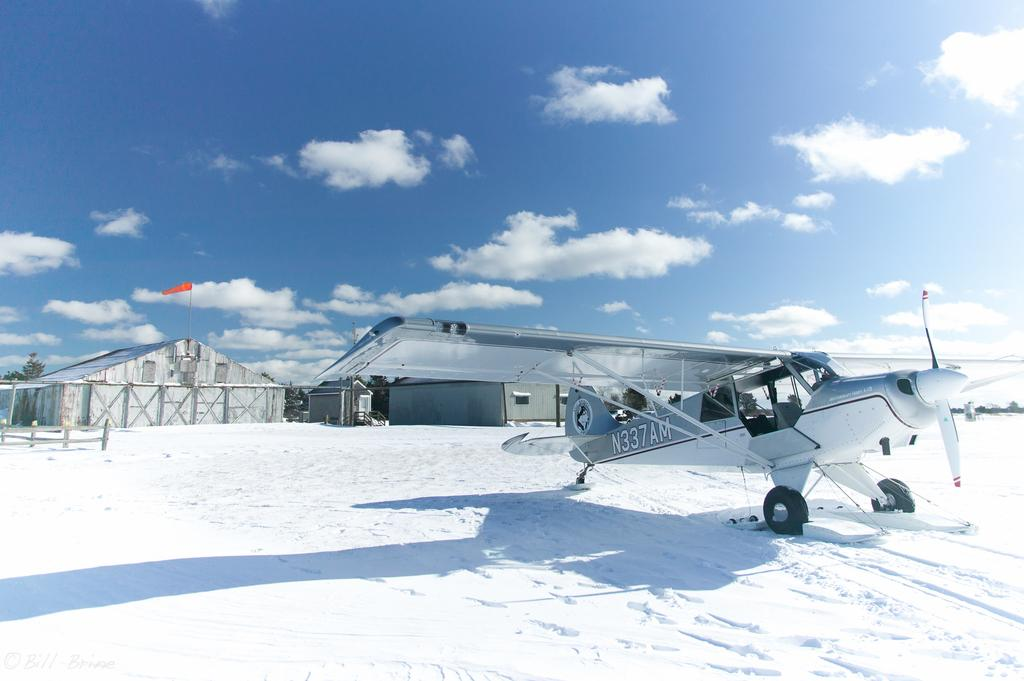What is located on the snowy ground in the image? There is a plane on the snowy ground in the image. Where is the plane positioned in relation to the image? The plane is at the bottom of the image. What structure can be seen in the middle of the image? There is a shelter in the middle of the image. What is the condition of the sky in the image? The sky is cloudy at the top of the image. What type of quarter is being used to play music in the image? There is no quarter or music playing in the image; it features a plane on the snowy ground, a shelter, and a cloudy sky. Is there a party happening in the image? There is no indication of a party in the image; it shows a plane, a shelter, and a cloudy sky. 